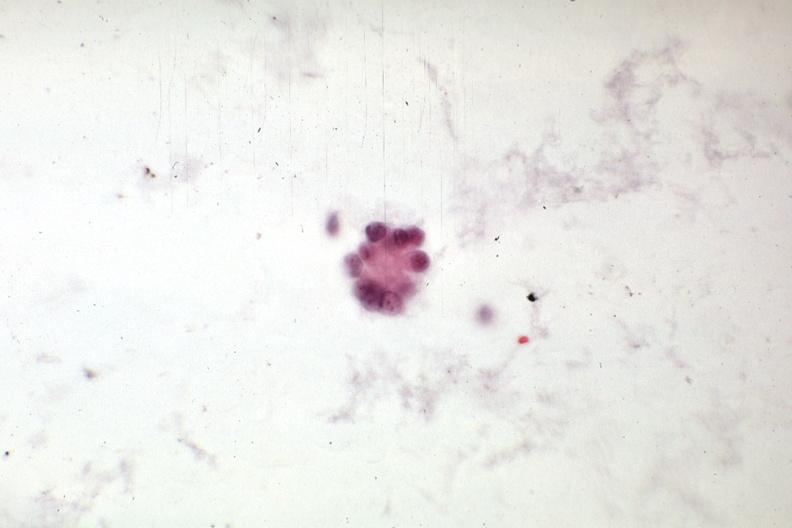s tuberculous peritonitis present?
Answer the question using a single word or phrase. No 